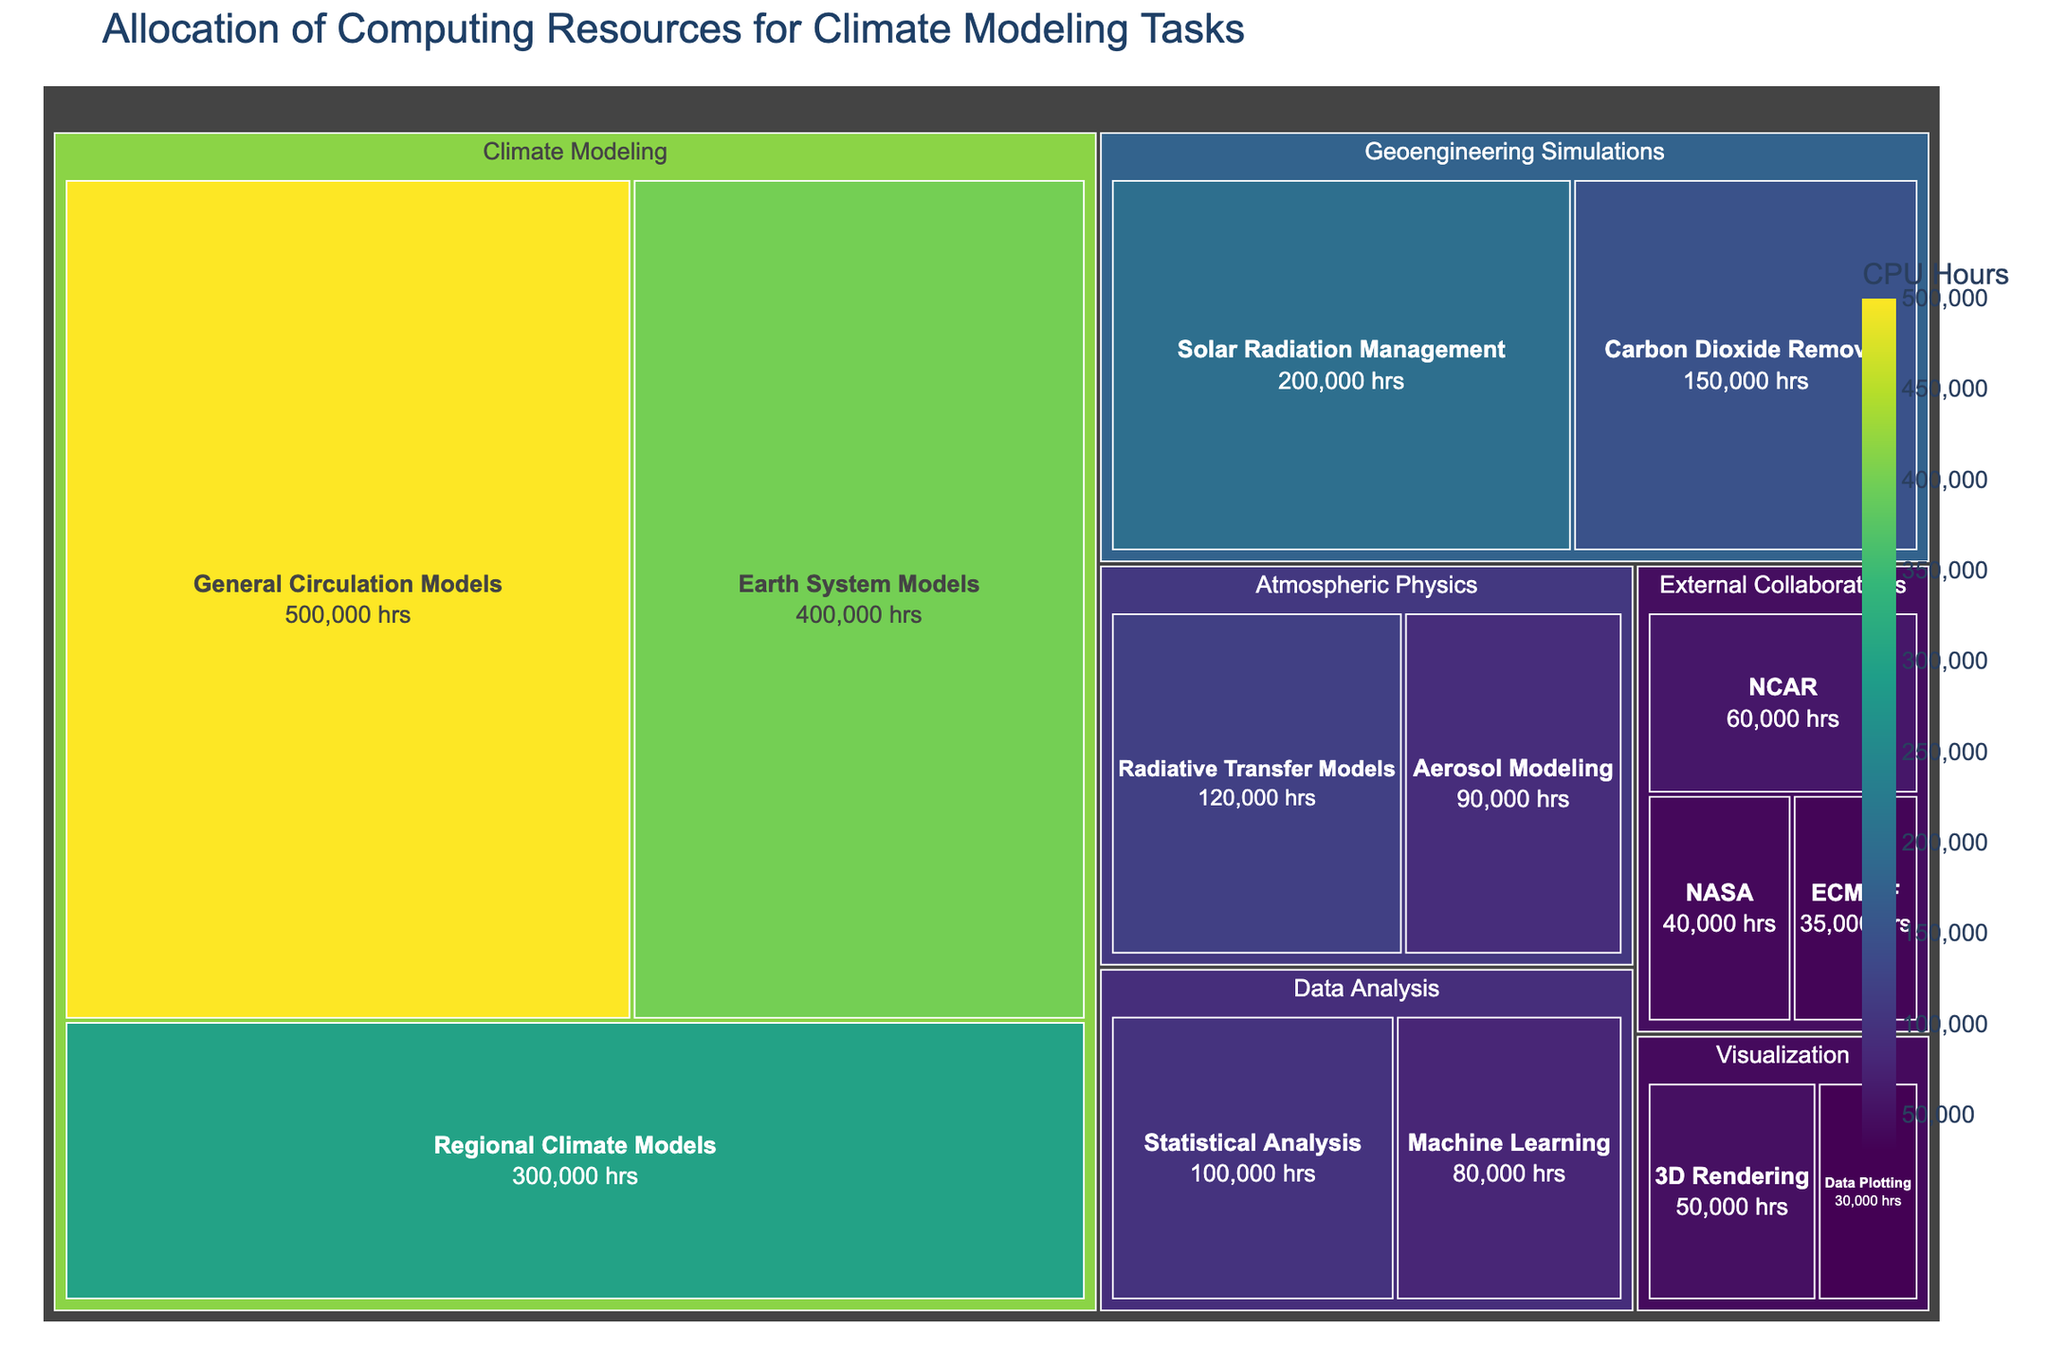What is the title of the figure? The title is the textual element at the top of the figure, which describes what the figure is about. The title here reads "Allocation of Computing Resources for Climate Modeling Tasks".
Answer: Allocation of Computing Resources for Climate Modeling Tasks Which subcategory has the most computing resources allocated? The subcategory with the largest area in the treemap represents the most computing resources allocated. By observation, "General Circulation Models" has the largest block.
Answer: General Circulation Models How many hours are dedicated to Geoengineering Simulations in total? Sum the CPU hours for "Solar Radiation Management" and "Carbon Dioxide Removal". These values are 200,000 and 150,000 respectively.
Answer: 350,000 hrs Which has more computing resources allocated: External Collaborations or Atmospheric Physics? Compare the total CPU hours allocated to both categories. Summing up the values for External Collaborations (60000 + 40000 + 35000 = 135000) and Atmospheric Physics (120000 + 90000 = 210000).
Answer: Atmospheric Physics What is the smallest subcategory in terms of computing resources? Identify the smallest block in the treemap. The smallest block corresponds to "Data Plotting" under the Visualization category, which has 30,000 CPU Hours.
Answer: Data Plotting How much more computing resources are allocated to Regional Climate Models compared to Radiative Transfer Models? Subtract the CPU Hours for Radiative Transfer Models (120,000) from Regional Climate Models (300,000).
Answer: 180,000 hrs Which subcategory of Data Analysis has fewer resources allocated? Compare the blocks for "Statistical Analysis" and "Machine Learning" under Data Analysis. "Machine Learning" has fewer resources.
Answer: Machine Learning What is the color scale used in the treemap? The treemap uses a continuous color scale to represent CPU hours, with a gradient from lighter to darker shades. The scale mentioned is "Viridis".
Answer: Viridis Sum the computing resources allocated to Atmospheric Physics and Visualization categories. Add the CPU hours for Atmospheric Physics (120,000 + 90,000 = 210,000) and Visualization (50,000 + 30,000 = 80,000) to get the total.
Answer: 290,000 hrs What is the average CPU hours allocated to the Earth System Models and Solar Radiation Management subcategories? Sum the CPU hours for both subcategories (400,000 + 200,000) and divide by 2.
Answer: 300,000 hrs 